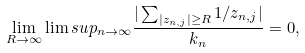<formula> <loc_0><loc_0><loc_500><loc_500>\lim _ { R \rightarrow \infty } \lim s u p _ { n \rightarrow \infty } \frac { | \sum _ { | z _ { n , j } | \geq R } 1 / z _ { n , j } | } { k _ { n } } = 0 ,</formula> 